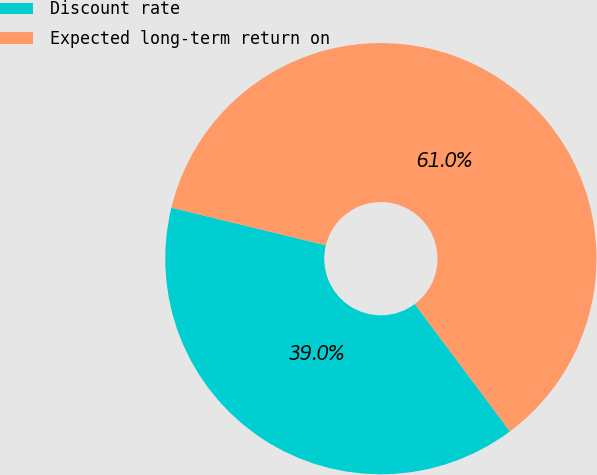<chart> <loc_0><loc_0><loc_500><loc_500><pie_chart><fcel>Discount rate<fcel>Expected long-term return on<nl><fcel>39.02%<fcel>60.98%<nl></chart> 